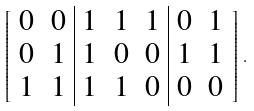<formula> <loc_0><loc_0><loc_500><loc_500>\left [ \begin{array} { c c | c c c | c c } 0 & 0 & 1 & 1 & 1 & 0 & 1 \\ 0 & 1 & 1 & 0 & 0 & 1 & 1 \\ 1 & 1 & 1 & 1 & 0 & 0 & 0 \end{array} \right ] \, .</formula> 